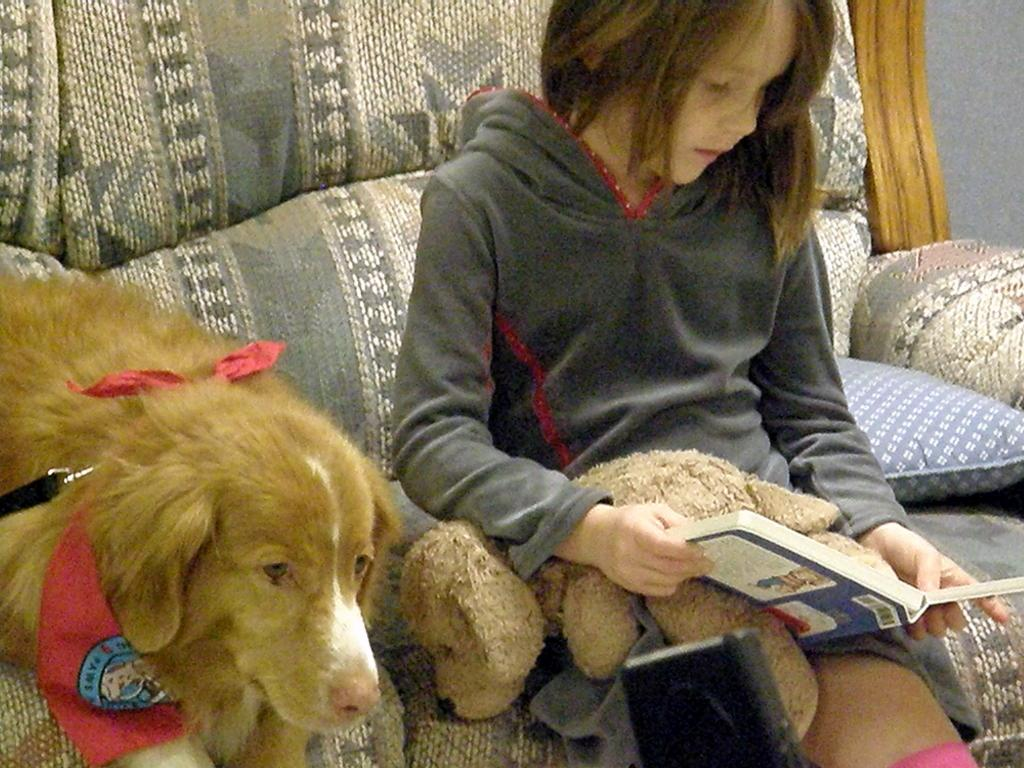Who is the main subject in the image? There is a girl in the image. What is the girl doing in the image? The girl is sitting on a sofa and reading a book. What is the girl holding or interacting with in the image? The girl has a toy on her lap. Is there any other living creature present in the image? Yes, there is a dog sitting beside the girl. What type of cabbage is growing on the girl's head in the image? There is no cabbage present in the image, nor is it growing on the girl's head. 